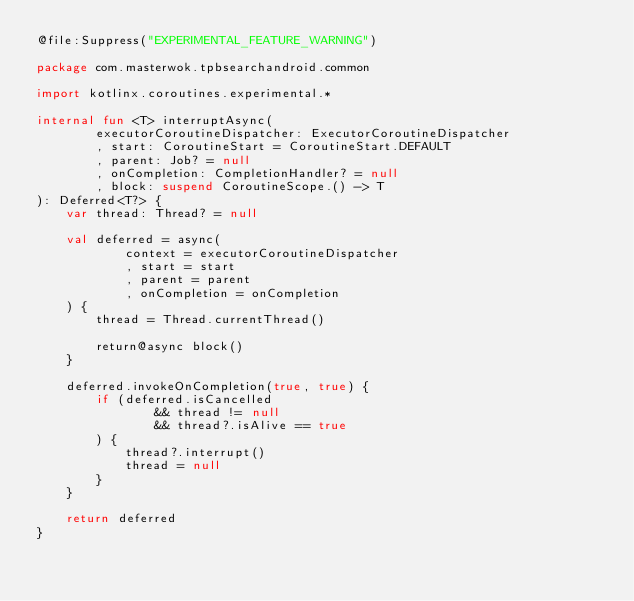Convert code to text. <code><loc_0><loc_0><loc_500><loc_500><_Kotlin_>@file:Suppress("EXPERIMENTAL_FEATURE_WARNING")

package com.masterwok.tpbsearchandroid.common

import kotlinx.coroutines.experimental.*

internal fun <T> interruptAsync(
        executorCoroutineDispatcher: ExecutorCoroutineDispatcher
        , start: CoroutineStart = CoroutineStart.DEFAULT
        , parent: Job? = null
        , onCompletion: CompletionHandler? = null
        , block: suspend CoroutineScope.() -> T
): Deferred<T?> {
    var thread: Thread? = null

    val deferred = async(
            context = executorCoroutineDispatcher
            , start = start
            , parent = parent
            , onCompletion = onCompletion
    ) {
        thread = Thread.currentThread()

        return@async block()
    }

    deferred.invokeOnCompletion(true, true) {
        if (deferred.isCancelled
                && thread != null
                && thread?.isAlive == true
        ) {
            thread?.interrupt()
            thread = null
        }
    }

    return deferred
}

</code> 